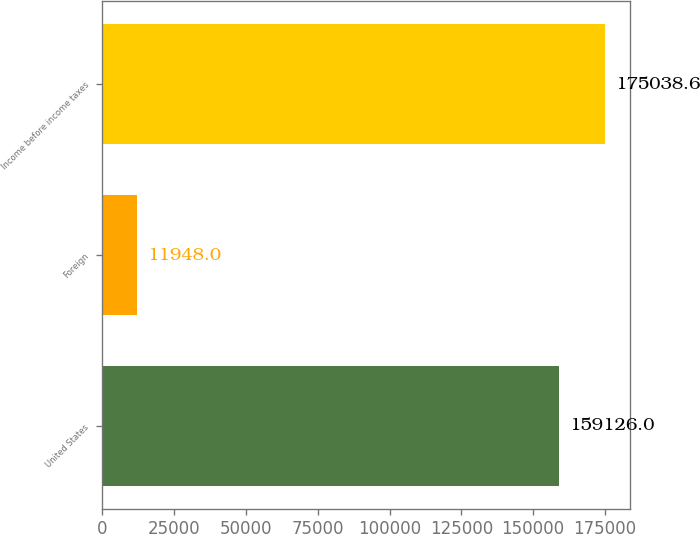Convert chart to OTSL. <chart><loc_0><loc_0><loc_500><loc_500><bar_chart><fcel>United States<fcel>Foreign<fcel>Income before income taxes<nl><fcel>159126<fcel>11948<fcel>175039<nl></chart> 